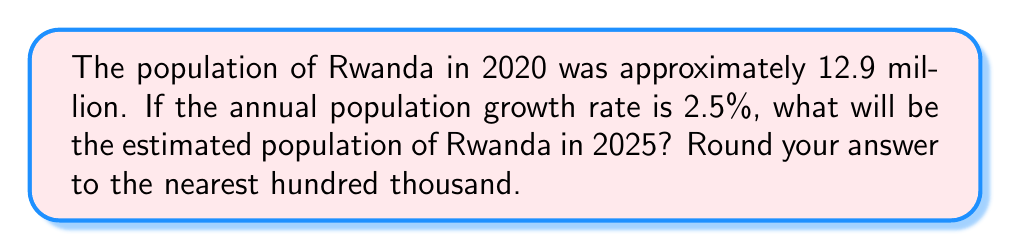Give your solution to this math problem. To solve this problem, we'll use the compound growth formula:

$$P(t) = P_0 \cdot (1 + r)^t$$

Where:
$P(t)$ is the population after time $t$
$P_0$ is the initial population
$r$ is the annual growth rate
$t$ is the number of years

Given:
$P_0 = 12.9$ million
$r = 2.5\% = 0.025$
$t = 5$ years (from 2020 to 2025)

Let's calculate:

$$\begin{align}
P(5) &= 12.9 \cdot (1 + 0.025)^5 \\
&= 12.9 \cdot (1.025)^5 \\
&= 12.9 \cdot 1.1314 \\
&= 14.5950 \text{ million}
\end{align}$$

Rounding to the nearest hundred thousand:

$$14.5950 \text{ million} \approx 14.6 \text{ million}$$
Answer: 14.6 million 